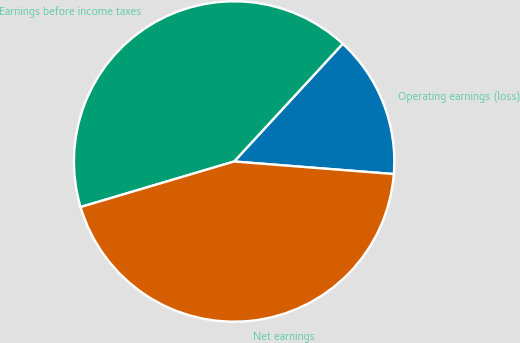<chart> <loc_0><loc_0><loc_500><loc_500><pie_chart><fcel>Operating earnings (loss)<fcel>Earnings before income taxes<fcel>Net earnings<nl><fcel>14.39%<fcel>41.45%<fcel>44.16%<nl></chart> 